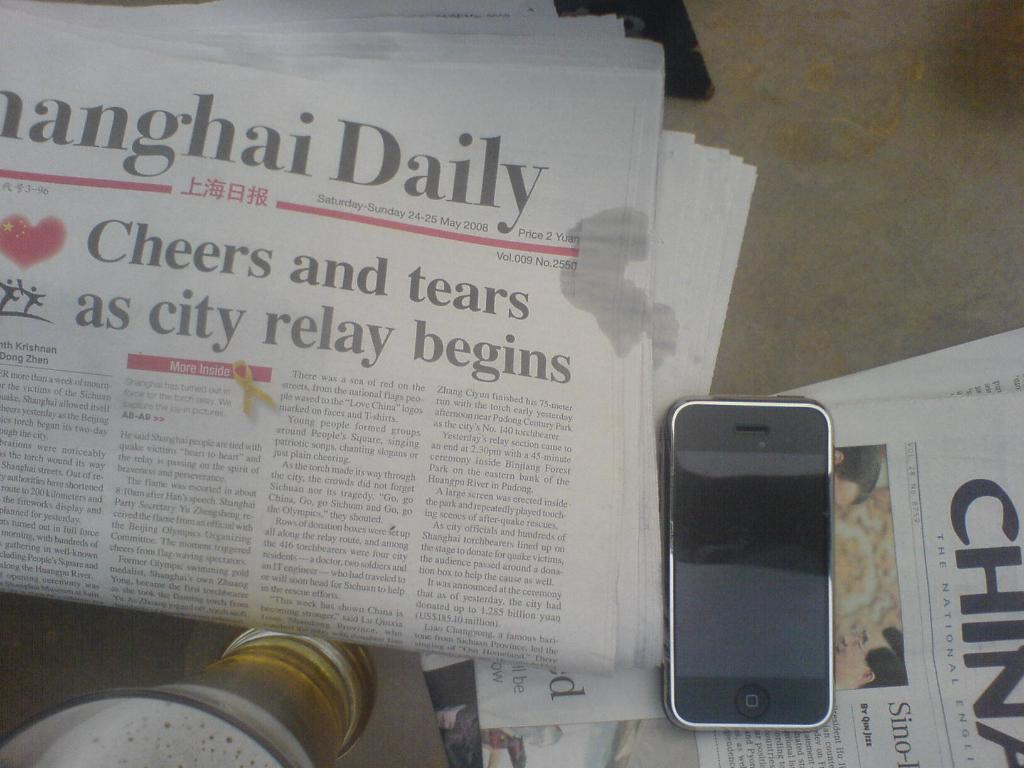<image>
Provide a brief description of the given image. A newspaper that was published by the Shanghai Daily. 